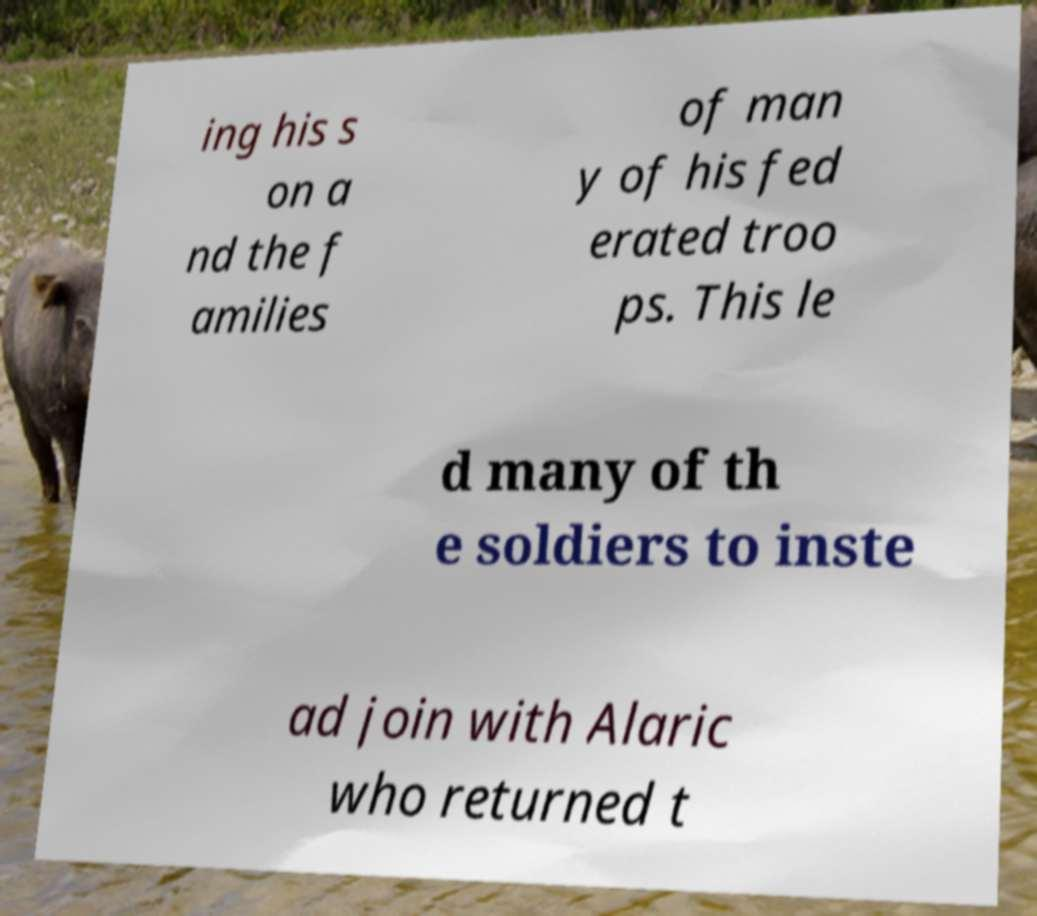Can you accurately transcribe the text from the provided image for me? ing his s on a nd the f amilies of man y of his fed erated troo ps. This le d many of th e soldiers to inste ad join with Alaric who returned t 